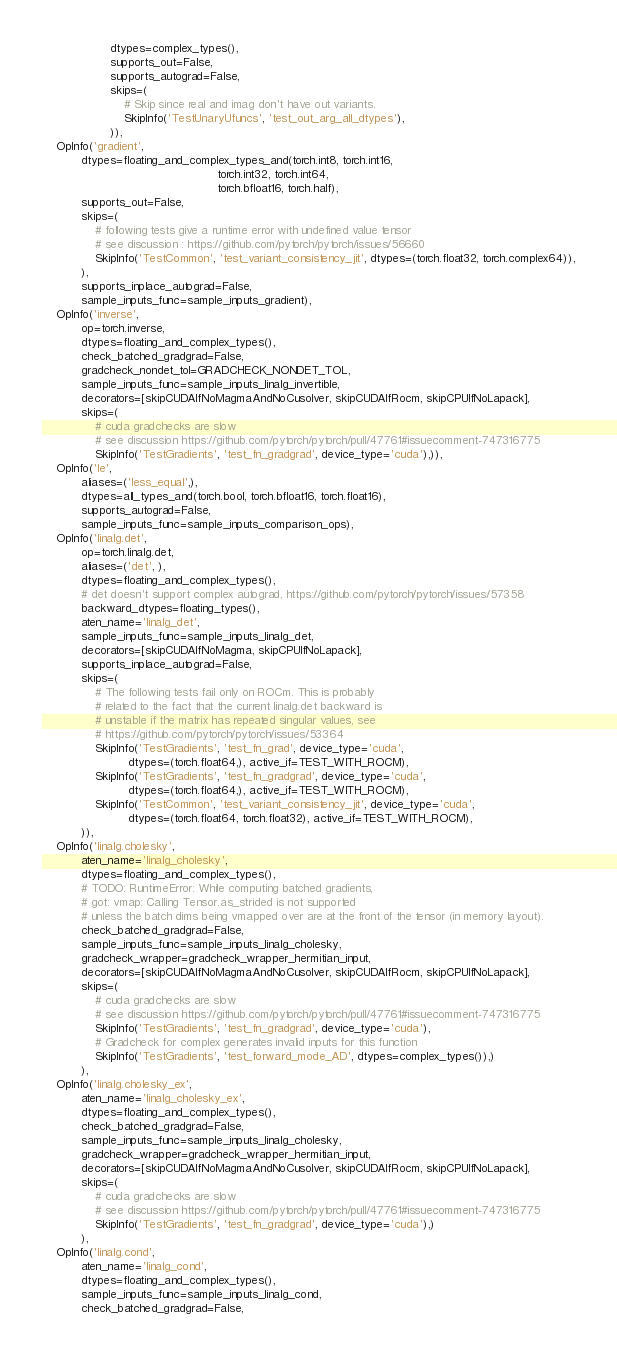<code> <loc_0><loc_0><loc_500><loc_500><_Python_>                   dtypes=complex_types(),
                   supports_out=False,
                   supports_autograd=False,
                   skips=(
                       # Skip since real and imag don't have out variants.
                       SkipInfo('TestUnaryUfuncs', 'test_out_arg_all_dtypes'),
                   )),
    OpInfo('gradient',
           dtypes=floating_and_complex_types_and(torch.int8, torch.int16,
                                                 torch.int32, torch.int64,
                                                 torch.bfloat16, torch.half),
           supports_out=False,
           skips=(
               # following tests give a runtime error with undefined value tensor
               # see discussion : https://github.com/pytorch/pytorch/issues/56660
               SkipInfo('TestCommon', 'test_variant_consistency_jit', dtypes=(torch.float32, torch.complex64)),
           ),
           supports_inplace_autograd=False,
           sample_inputs_func=sample_inputs_gradient),
    OpInfo('inverse',
           op=torch.inverse,
           dtypes=floating_and_complex_types(),
           check_batched_gradgrad=False,
           gradcheck_nondet_tol=GRADCHECK_NONDET_TOL,
           sample_inputs_func=sample_inputs_linalg_invertible,
           decorators=[skipCUDAIfNoMagmaAndNoCusolver, skipCUDAIfRocm, skipCPUIfNoLapack],
           skips=(
               # cuda gradchecks are slow
               # see discussion https://github.com/pytorch/pytorch/pull/47761#issuecomment-747316775
               SkipInfo('TestGradients', 'test_fn_gradgrad', device_type='cuda'),)),
    OpInfo('le',
           aliases=('less_equal',),
           dtypes=all_types_and(torch.bool, torch.bfloat16, torch.float16),
           supports_autograd=False,
           sample_inputs_func=sample_inputs_comparison_ops),
    OpInfo('linalg.det',
           op=torch.linalg.det,
           aliases=('det', ),
           dtypes=floating_and_complex_types(),
           # det doesn't support complex autograd, https://github.com/pytorch/pytorch/issues/57358
           backward_dtypes=floating_types(),
           aten_name='linalg_det',
           sample_inputs_func=sample_inputs_linalg_det,
           decorators=[skipCUDAIfNoMagma, skipCPUIfNoLapack],
           supports_inplace_autograd=False,
           skips=(
               # The following tests fail only on ROCm. This is probably
               # related to the fact that the current linalg.det backward is
               # unstable if the matrix has repeated singular values, see
               # https://github.com/pytorch/pytorch/issues/53364
               SkipInfo('TestGradients', 'test_fn_grad', device_type='cuda',
                        dtypes=(torch.float64,), active_if=TEST_WITH_ROCM),
               SkipInfo('TestGradients', 'test_fn_gradgrad', device_type='cuda',
                        dtypes=(torch.float64,), active_if=TEST_WITH_ROCM),
               SkipInfo('TestCommon', 'test_variant_consistency_jit', device_type='cuda',
                        dtypes=(torch.float64, torch.float32), active_if=TEST_WITH_ROCM),
           )),
    OpInfo('linalg.cholesky',
           aten_name='linalg_cholesky',
           dtypes=floating_and_complex_types(),
           # TODO: RuntimeError: While computing batched gradients,
           # got: vmap: Calling Tensor.as_strided is not supported
           # unless the batch dims being vmapped over are at the front of the tensor (in memory layout).
           check_batched_gradgrad=False,
           sample_inputs_func=sample_inputs_linalg_cholesky,
           gradcheck_wrapper=gradcheck_wrapper_hermitian_input,
           decorators=[skipCUDAIfNoMagmaAndNoCusolver, skipCUDAIfRocm, skipCPUIfNoLapack],
           skips=(
               # cuda gradchecks are slow
               # see discussion https://github.com/pytorch/pytorch/pull/47761#issuecomment-747316775
               SkipInfo('TestGradients', 'test_fn_gradgrad', device_type='cuda'),
               # Gradcheck for complex generates invalid inputs for this function
               SkipInfo('TestGradients', 'test_forward_mode_AD', dtypes=complex_types()),)
           ),
    OpInfo('linalg.cholesky_ex',
           aten_name='linalg_cholesky_ex',
           dtypes=floating_and_complex_types(),
           check_batched_gradgrad=False,
           sample_inputs_func=sample_inputs_linalg_cholesky,
           gradcheck_wrapper=gradcheck_wrapper_hermitian_input,
           decorators=[skipCUDAIfNoMagmaAndNoCusolver, skipCUDAIfRocm, skipCPUIfNoLapack],
           skips=(
               # cuda gradchecks are slow
               # see discussion https://github.com/pytorch/pytorch/pull/47761#issuecomment-747316775
               SkipInfo('TestGradients', 'test_fn_gradgrad', device_type='cuda'),)
           ),
    OpInfo('linalg.cond',
           aten_name='linalg_cond',
           dtypes=floating_and_complex_types(),
           sample_inputs_func=sample_inputs_linalg_cond,
           check_batched_gradgrad=False,</code> 